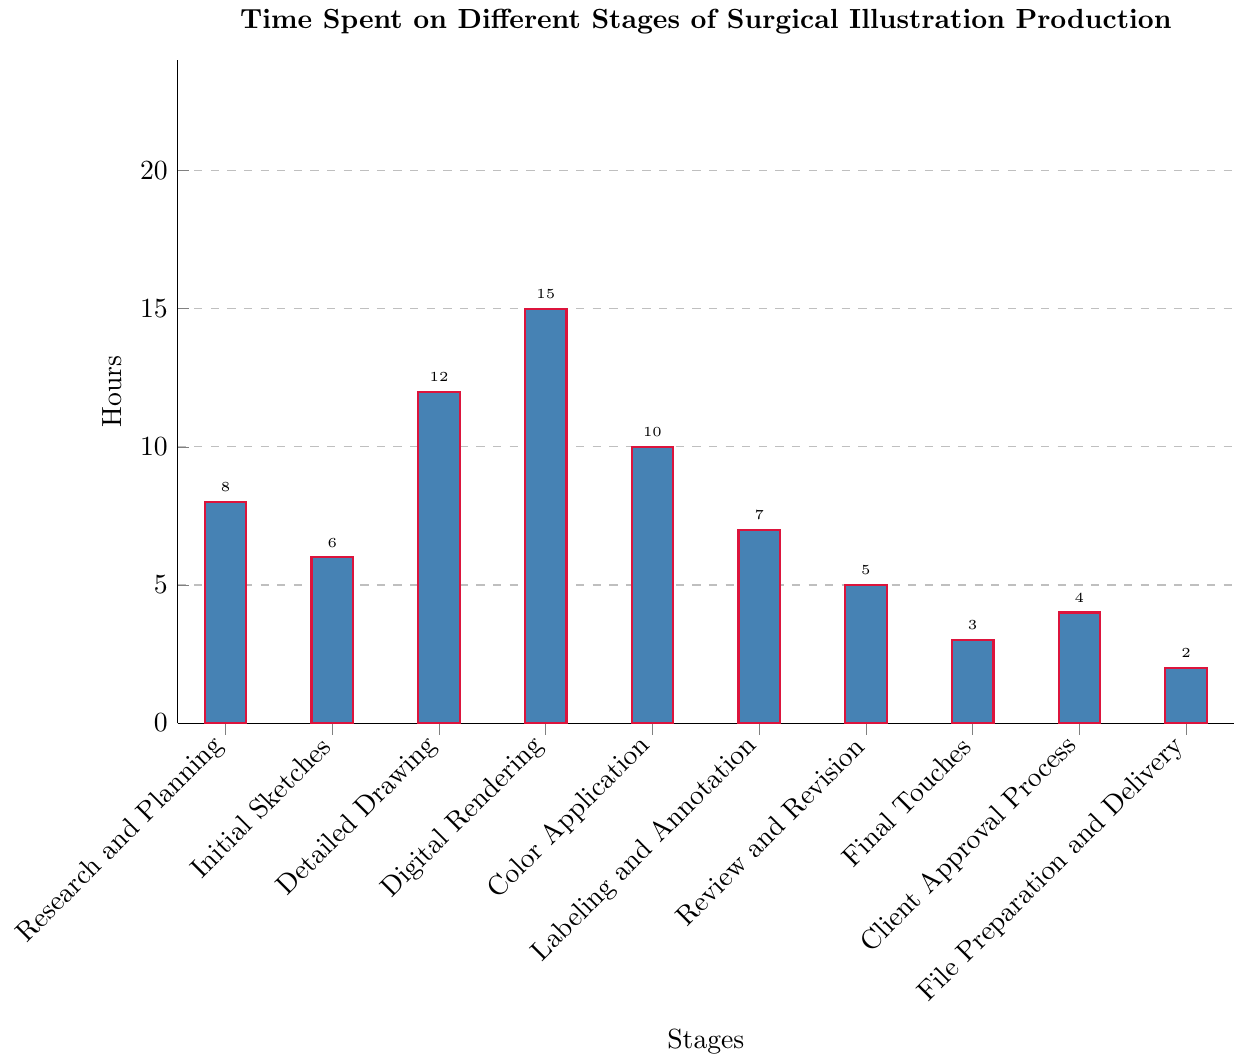What stage takes the longest amount of time? By examining the height of the bars, we can see that the stage "Digital Rendering" has the tallest bar, indicating it takes the longest amount of time.
Answer: Digital Rendering What is the total time spent on the initial three stages? The time for "Research and Planning" is 8 hours, "Initial Sketches" is 6 hours, and "Detailed Drawing" is 12 hours. Adding these gives 8 + 6 + 12 = 26 hours.
Answer: 26 hours Which takes more time: "Color Application" or "Labeling and Annotation"? By comparing the heights of the bars, "Color Application" (10 hours) is taller than "Labeling and Annotation" (7 hours), indicating it takes more time.
Answer: Color Application What is the sum of the time spent on the "Review and Revision" and "Final Touches" stages? The time for "Review and Revision" is 5 hours and for "Final Touches" is 3 hours. Adding these gives 5 + 3 = 8 hours.
Answer: 8 hours What is the average time spent across all stages? Sum all the times: 8 (Research and Planning) + 6 (Initial Sketches) + 12 (Detailed Drawing) + 15 (Digital Rendering) + 10 (Color Application) + 7 (Labeling and Annotation) + 5 (Review and Revision) + 3 (Final Touches) + 4 (Client Approval Process) + 2 (File Preparation and Delivery) = 72. Divide by the number of stages (10), so the average is 72 / 10 = 7.2 hours.
Answer: 7.2 hours How much less time is spent on "Client Approval Process" compared to "Detailed Drawing"? The time for "Client Approval Process" is 4 hours, and for "Detailed Drawing" is 12 hours. The difference is 12 - 4 = 8 hours.
Answer: 8 hours What is the median time spent on all stages? First, list the times in ascending order: 2, 3, 4, 5, 6, 7, 8, 10, 12, 15. The median is the average of the 5th and 6th numbers: (6 + 7) / 2 = 6.5 hours.
Answer: 6.5 hours Between "File Preparation and Delivery" and "Initial Sketches", which one takes less time? By comparing the heights of the bars, "File Preparation and Delivery" (2 hours) is shorter than "Initial Sketches" (6 hours).
Answer: File Preparation and Delivery 